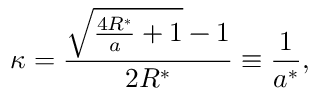<formula> <loc_0><loc_0><loc_500><loc_500>\kappa = \frac { \sqrt { \frac { 4 R ^ { * } } { a } + 1 } - 1 } { 2 R ^ { * } } \equiv \frac { 1 } { a ^ { * } } ,</formula> 